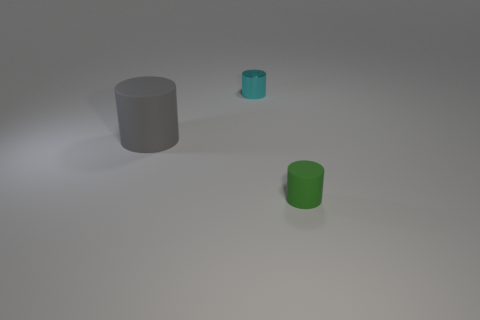Can you describe the lighting in the image? The lighting in the image gives off a soft diffused appearance, casting gentle shadows that suggest an ambient light source above the scene. 